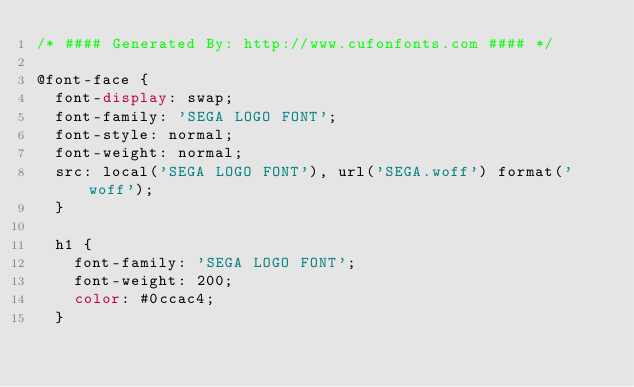<code> <loc_0><loc_0><loc_500><loc_500><_CSS_>/* #### Generated By: http://www.cufonfonts.com #### */

@font-face {
  font-display: swap;
  font-family: 'SEGA LOGO FONT';
  font-style: normal;
  font-weight: normal;
  src: local('SEGA LOGO FONT'), url('SEGA.woff') format('woff');
  }
  
  h1 {
    font-family: 'SEGA LOGO FONT';
    font-weight: 200;
    color: #0ccac4;
  }</code> 